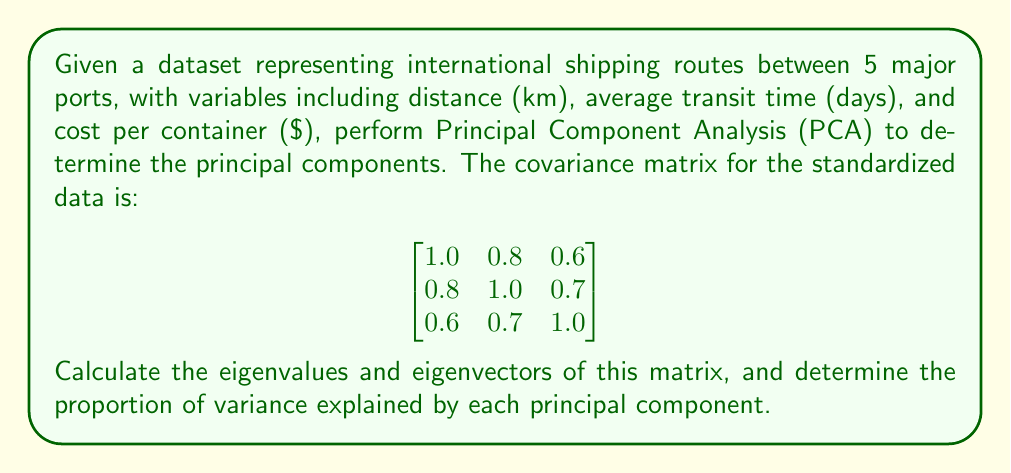Give your solution to this math problem. 1. To find the principal components, we need to calculate the eigenvalues and eigenvectors of the covariance matrix.

2. The characteristic equation is:
   $$\det(\lambda I - A) = 0$$
   where $A$ is the covariance matrix and $\lambda$ are the eigenvalues.

3. Expanding the determinant:
   $$(\lambda - 1)((\lambda - 1)(\lambda - 1) - 0.49) - 0.8(0.8(\lambda - 1) - 0.42) + 0.6(0.56 - 0.7(\lambda - 1)) = 0$$

4. Simplifying:
   $$\lambda^3 - 3\lambda^2 + 2.51\lambda - 0.49 = 0$$

5. Solving this equation (using numerical methods) gives us the eigenvalues:
   $$\lambda_1 \approx 2.3741, \lambda_2 \approx 0.5259, \lambda_3 \approx 0.1000$$

6. For each eigenvalue, we solve $(A - \lambda I)v = 0$ to find the corresponding eigenvector:

   For $\lambda_1 \approx 2.3741$:
   $$v_1 \approx [0.5776, 0.6021, 0.5511]^T$$

   For $\lambda_2 \approx 0.5259$:
   $$v_2 \approx [-0.6908, 0.0644, 0.7204]^T$$

   For $\lambda_3 \approx 0.1000$:
   $$v_3 \approx [0.4339, -0.7959, 0.4220]^T$$

7. The proportion of variance explained by each principal component is calculated by dividing each eigenvalue by the sum of all eigenvalues:

   $$\text{Proportion}_1 = \frac{2.3741}{2.3741 + 0.5259 + 0.1000} \approx 0.7914$$
   $$\text{Proportion}_2 = \frac{0.5259}{2.3741 + 0.5259 + 0.1000} \approx 0.1753$$
   $$\text{Proportion}_3 = \frac{0.1000}{2.3741 + 0.5259 + 0.1000} \approx 0.0333$$
Answer: Eigenvalues: $\lambda_1 \approx 2.3741, \lambda_2 \approx 0.5259, \lambda_3 \approx 0.1000$
Eigenvectors: $v_1 \approx [0.5776, 0.6021, 0.5511]^T, v_2 \approx [-0.6908, 0.0644, 0.7204]^T, v_3 \approx [0.4339, -0.7959, 0.4220]^T$
Proportions of variance: $79.14\%, 17.53\%, 3.33\%$ 